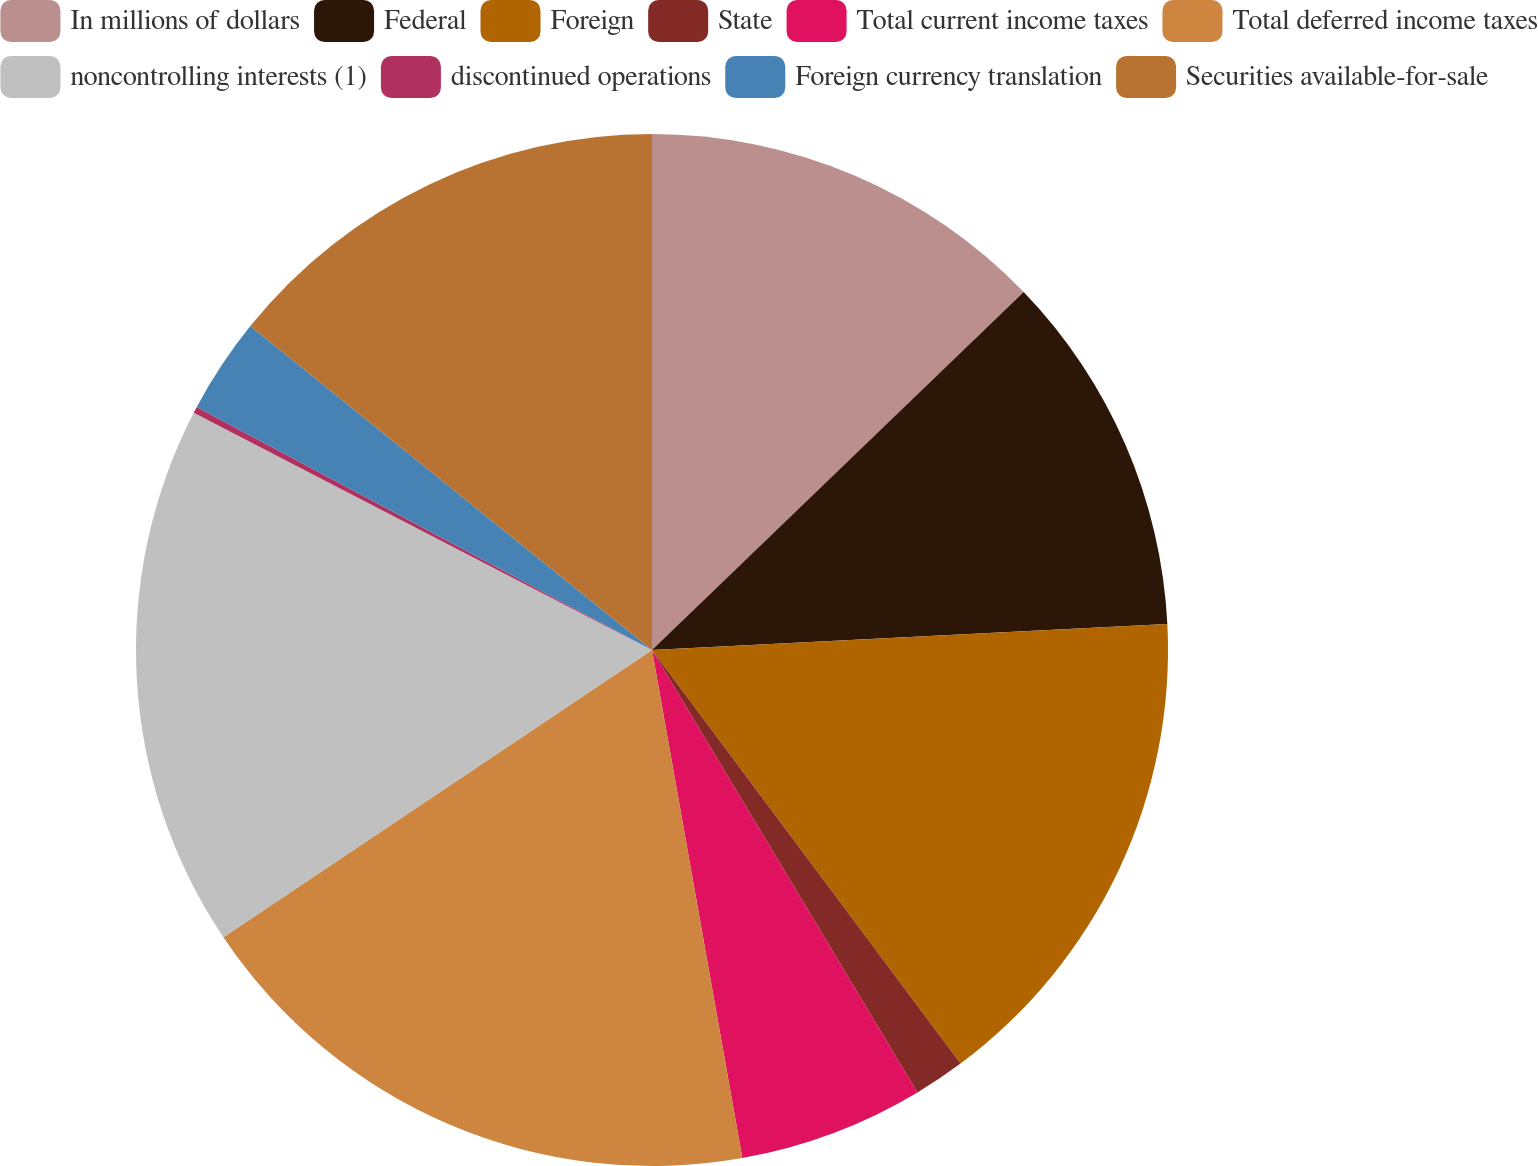<chart> <loc_0><loc_0><loc_500><loc_500><pie_chart><fcel>In millions of dollars<fcel>Federal<fcel>Foreign<fcel>State<fcel>Total current income taxes<fcel>Total deferred income taxes<fcel>noncontrolling interests (1)<fcel>discontinued operations<fcel>Foreign currency translation<fcel>Securities available-for-sale<nl><fcel>12.8%<fcel>11.4%<fcel>15.6%<fcel>1.6%<fcel>5.8%<fcel>18.4%<fcel>17.0%<fcel>0.2%<fcel>3.0%<fcel>14.2%<nl></chart> 